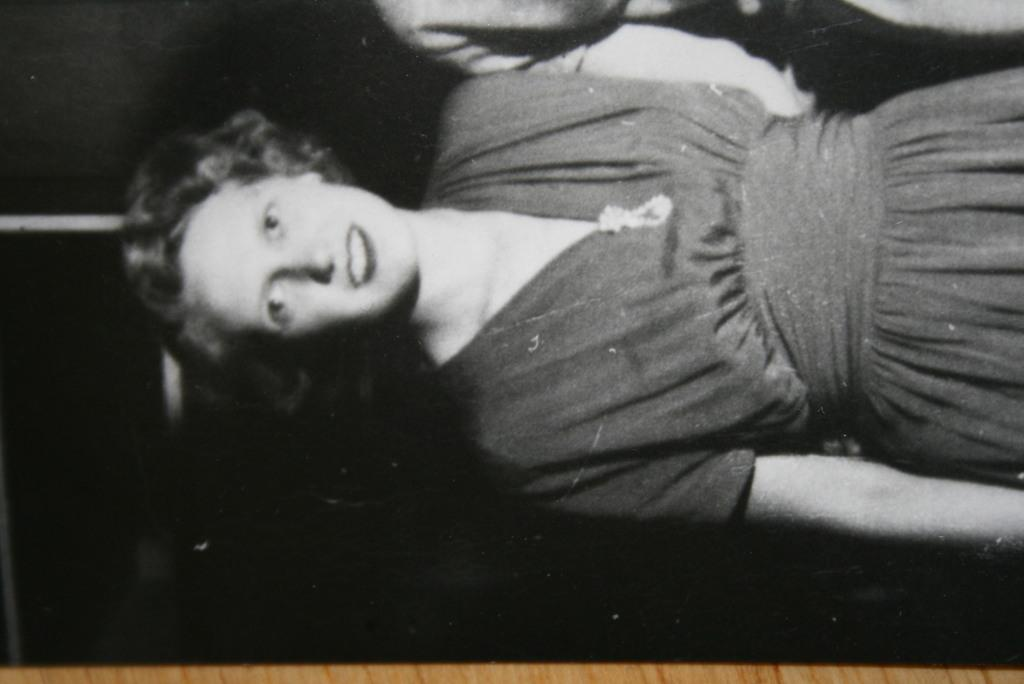What is the color scheme of the image? The image is in black and white. Can you describe the person in the image? There is a person wearing clothes in the image. What else can be seen in the image? There is another person's hand at the top of the image. What type of egg is being held by the person in the image? There is no egg present in the image. What substance is being produced by the frog in the image? There is no frog present in the image. 